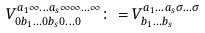Convert formula to latex. <formula><loc_0><loc_0><loc_500><loc_500>V ^ { a _ { 1 } \infty \dots a _ { s } \infty \infty \dots \infty } _ { 0 b _ { 1 } \dots 0 b _ { s } 0 \dots 0 } \colon = V ^ { a _ { 1 } \dots a _ { s } \sigma \dots \sigma } _ { b _ { 1 } \dots b _ { s } }</formula> 